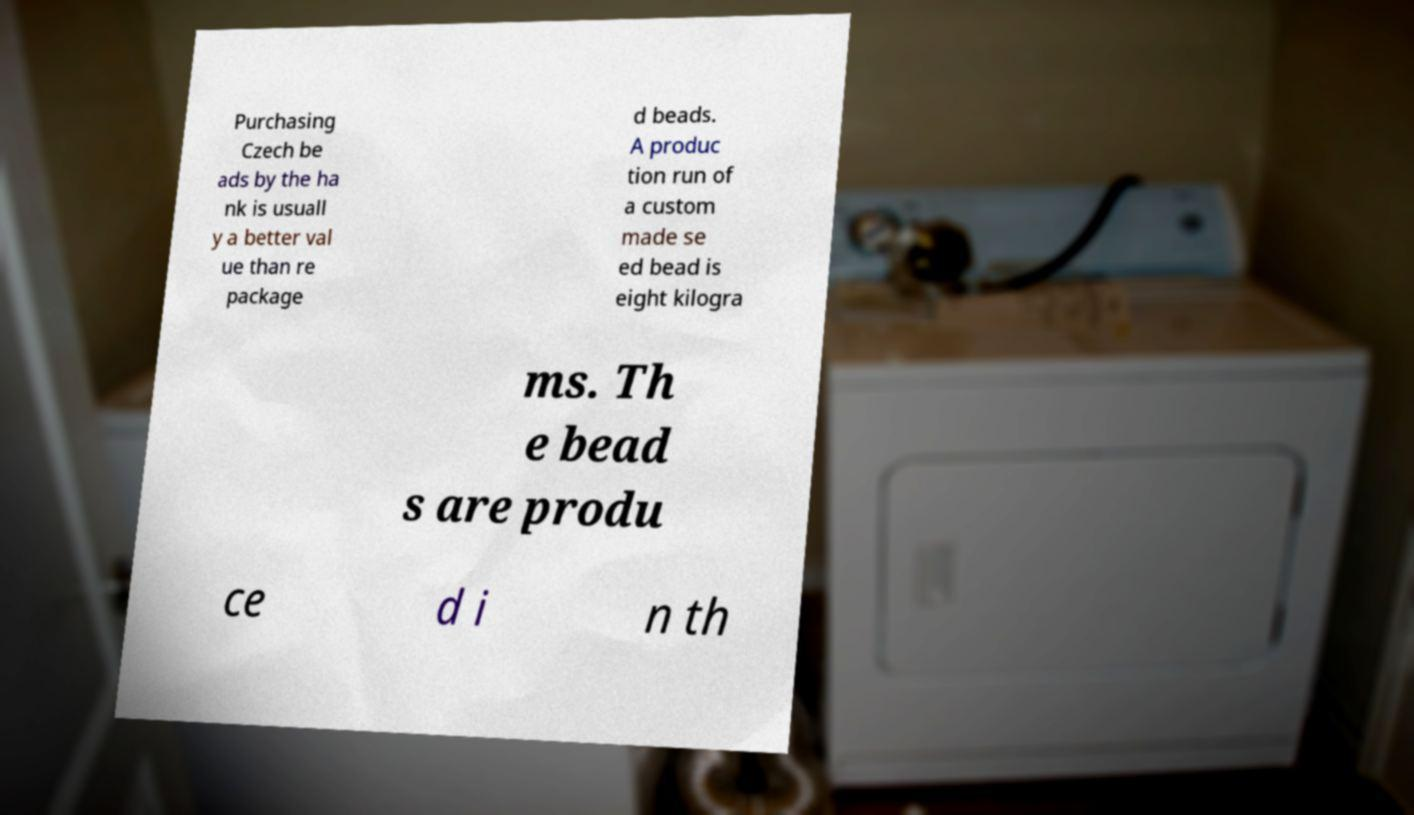Please identify and transcribe the text found in this image. Purchasing Czech be ads by the ha nk is usuall y a better val ue than re package d beads. A produc tion run of a custom made se ed bead is eight kilogra ms. Th e bead s are produ ce d i n th 